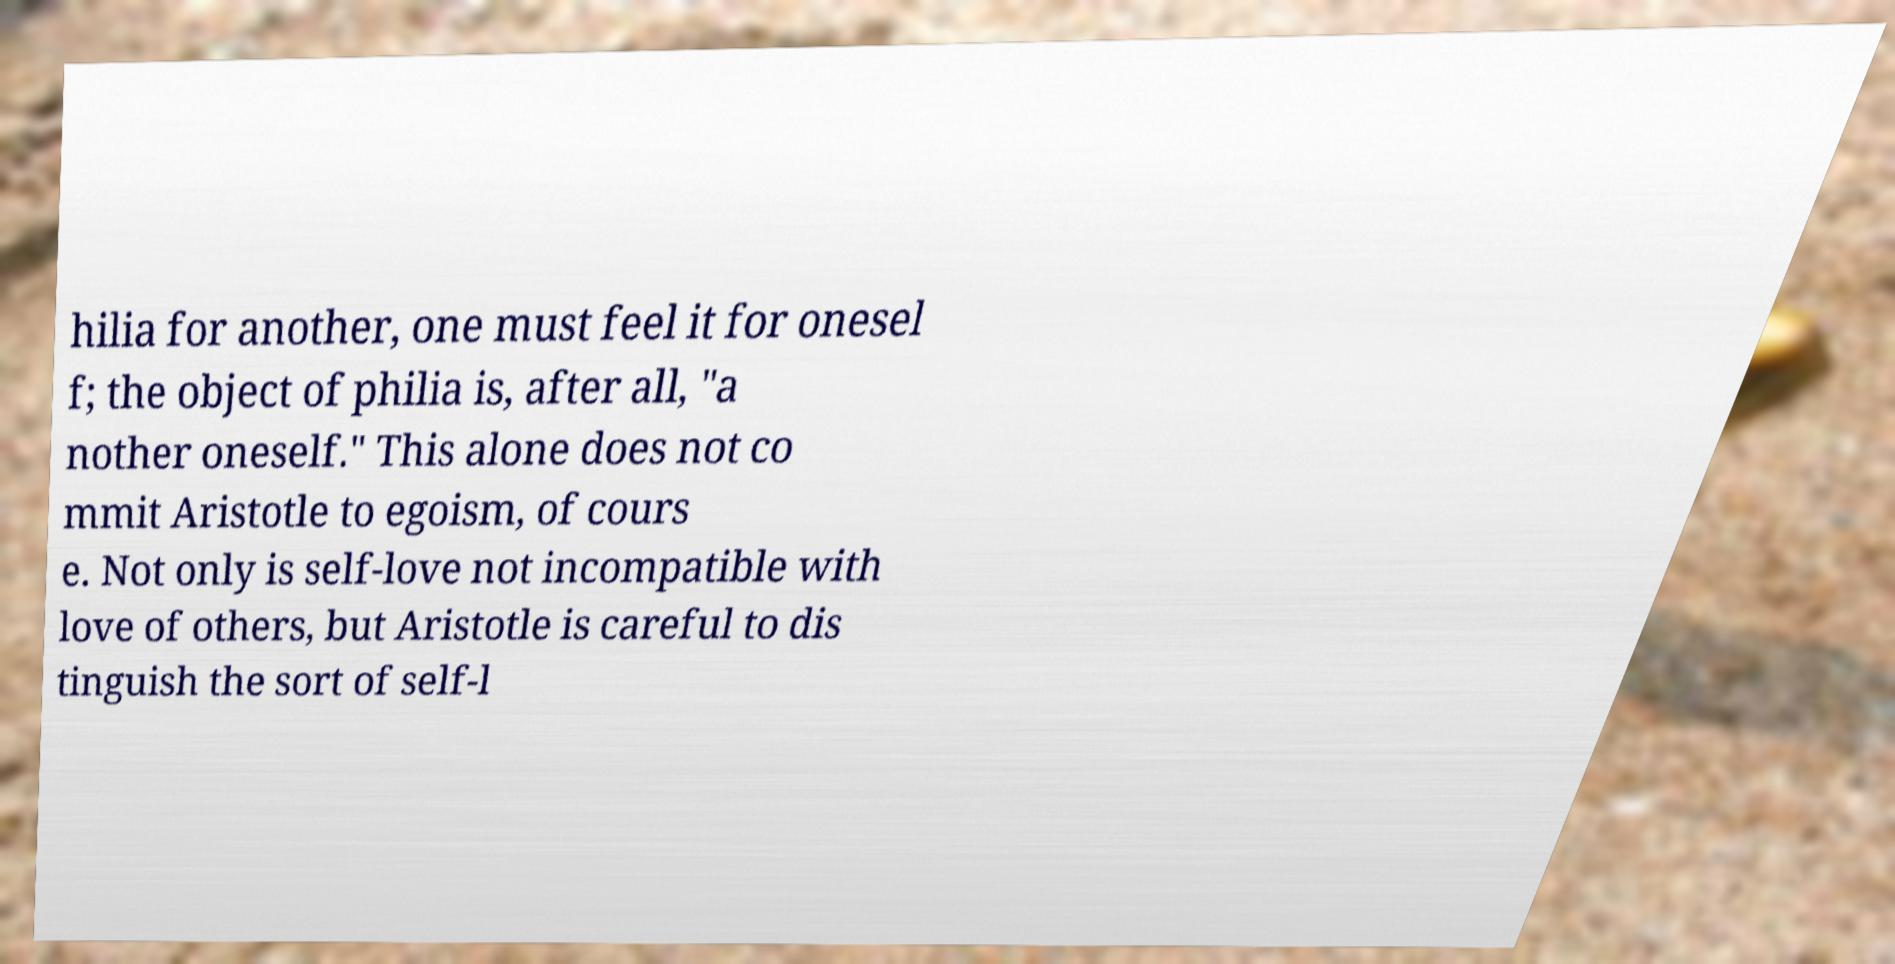Can you read and provide the text displayed in the image?This photo seems to have some interesting text. Can you extract and type it out for me? hilia for another, one must feel it for onesel f; the object of philia is, after all, "a nother oneself." This alone does not co mmit Aristotle to egoism, of cours e. Not only is self-love not incompatible with love of others, but Aristotle is careful to dis tinguish the sort of self-l 